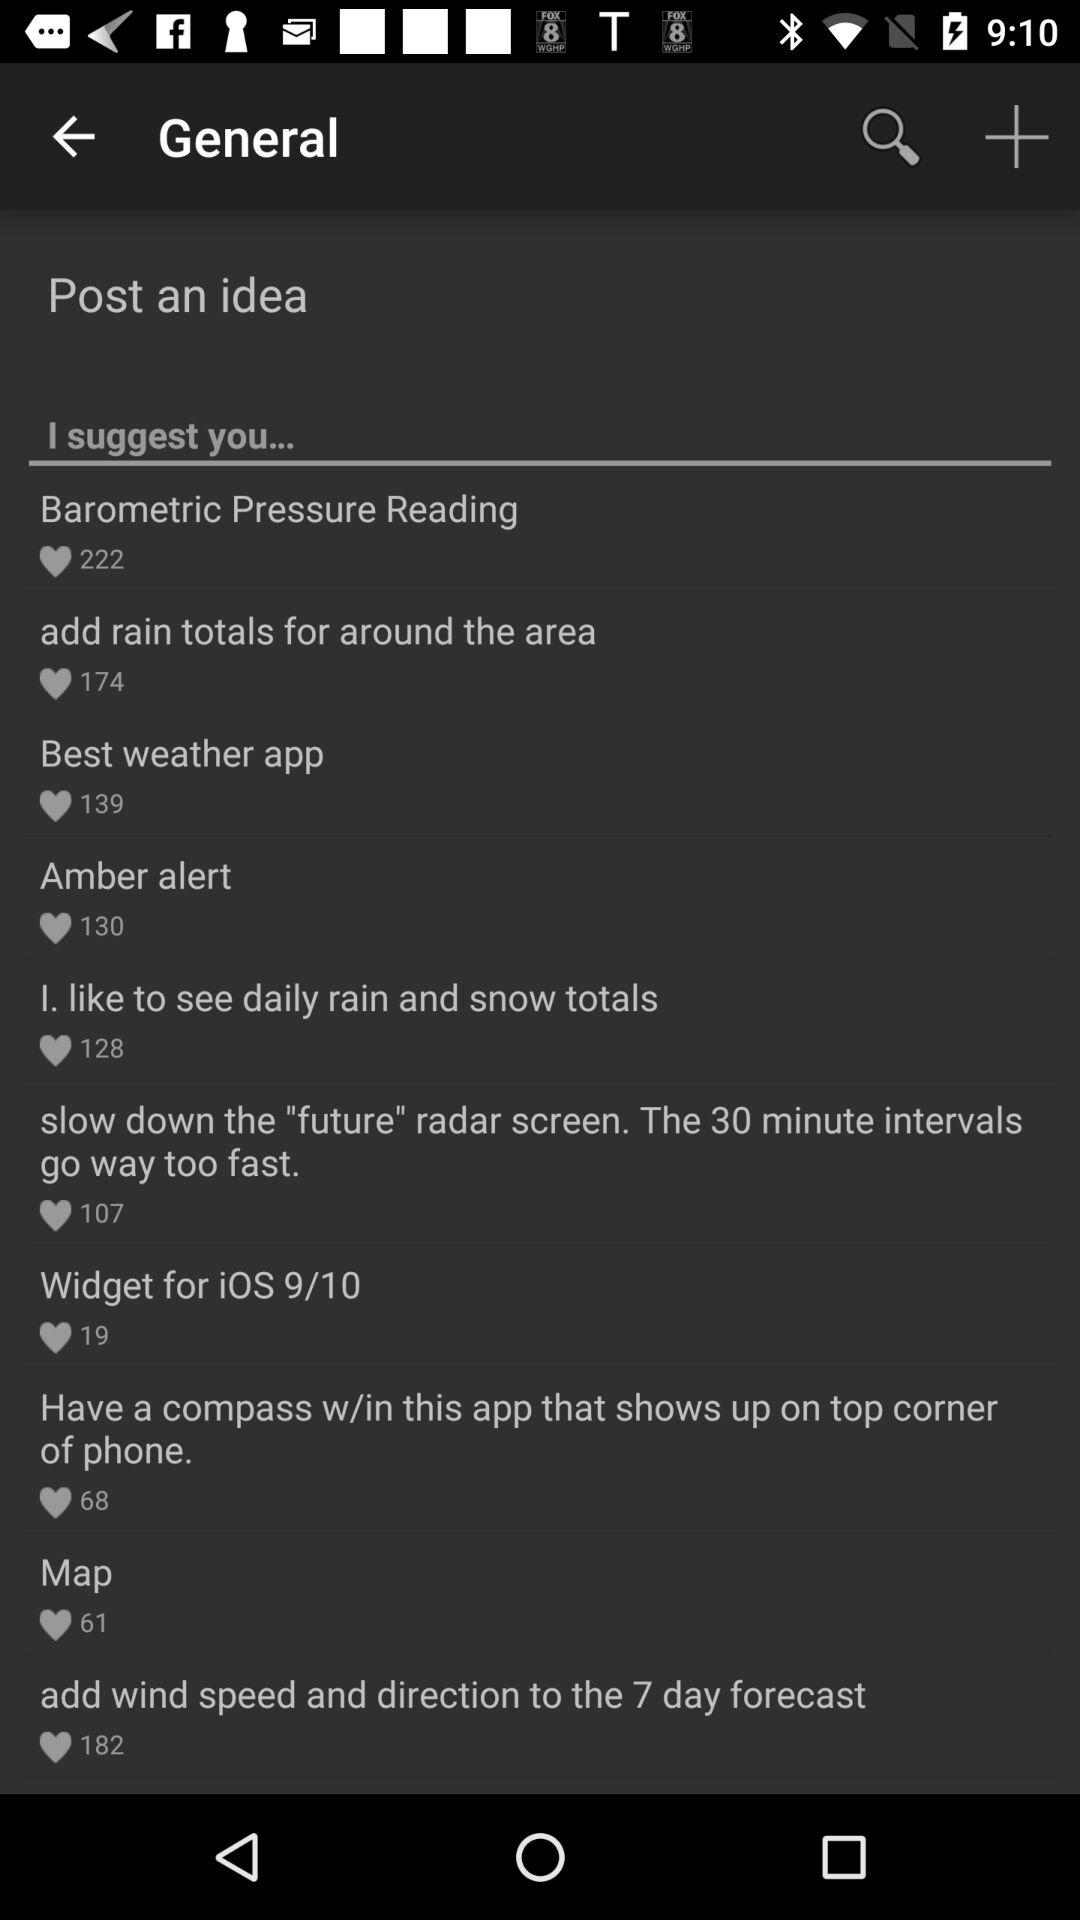What are the different ideas? The different ideas are "Barometric Pressure Reading", "add rain totals for around the area", "Best weather app", "Amber alert", "I. like to see daily rain and snow totals", "slow down the "future" radar screen. The 30 minute intervals go way too fast.", "Widget for iOS 9/10", "Have a compass w/in this app that shows up on top corner of phone.", "Map" and "add wind speed and direction to the 7 day forecast". 